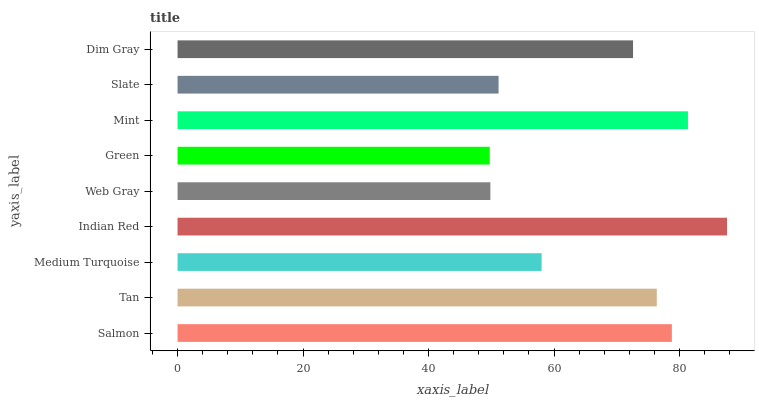Is Green the minimum?
Answer yes or no. Yes. Is Indian Red the maximum?
Answer yes or no. Yes. Is Tan the minimum?
Answer yes or no. No. Is Tan the maximum?
Answer yes or no. No. Is Salmon greater than Tan?
Answer yes or no. Yes. Is Tan less than Salmon?
Answer yes or no. Yes. Is Tan greater than Salmon?
Answer yes or no. No. Is Salmon less than Tan?
Answer yes or no. No. Is Dim Gray the high median?
Answer yes or no. Yes. Is Dim Gray the low median?
Answer yes or no. Yes. Is Tan the high median?
Answer yes or no. No. Is Medium Turquoise the low median?
Answer yes or no. No. 